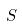<formula> <loc_0><loc_0><loc_500><loc_500>S</formula> 